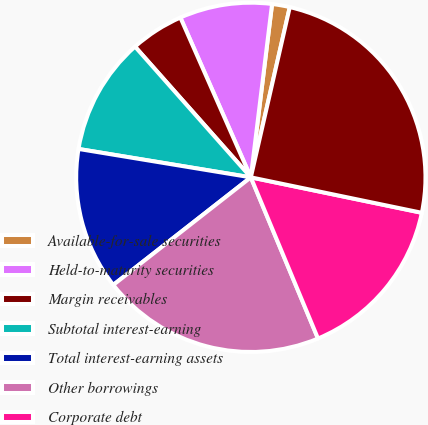<chart> <loc_0><loc_0><loc_500><loc_500><pie_chart><fcel>Available-for-sale securities<fcel>Held-to-maturity securities<fcel>Margin receivables<fcel>Subtotal interest-earning<fcel>Total interest-earning assets<fcel>Other borrowings<fcel>Corporate debt<fcel>Change in net interest income<nl><fcel>1.64%<fcel>8.55%<fcel>4.93%<fcel>10.86%<fcel>13.16%<fcel>20.72%<fcel>15.46%<fcel>24.67%<nl></chart> 